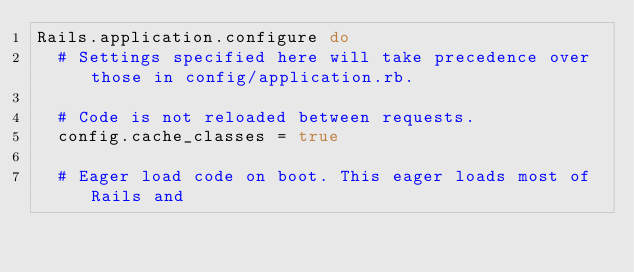<code> <loc_0><loc_0><loc_500><loc_500><_Ruby_>Rails.application.configure do
  # Settings specified here will take precedence over those in config/application.rb.

  # Code is not reloaded between requests.
  config.cache_classes = true

  # Eager load code on boot. This eager loads most of Rails and</code> 